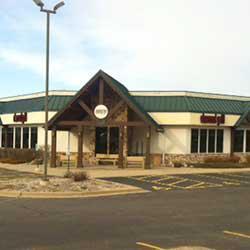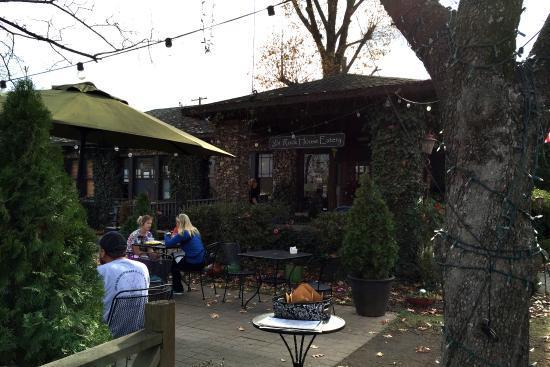The first image is the image on the left, the second image is the image on the right. Assess this claim about the two images: "In one image, an outdoor seating area in front of a building includes at least two solid-colored patio umbrellas.". Correct or not? Answer yes or no. No. The first image is the image on the left, the second image is the image on the right. Examine the images to the left and right. Is the description "There are at most 2 umbrellas in the image on the right." accurate? Answer yes or no. Yes. 